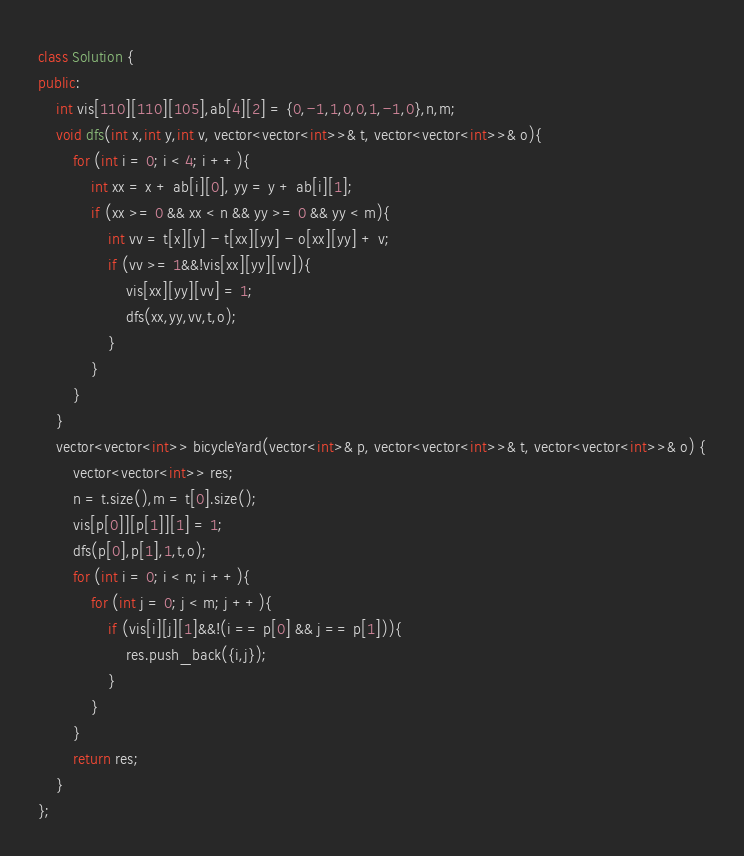Convert code to text. <code><loc_0><loc_0><loc_500><loc_500><_C++_>class Solution {
public:
    int vis[110][110][105],ab[4][2] = {0,-1,1,0,0,1,-1,0},n,m;
    void dfs(int x,int y,int v, vector<vector<int>>& t, vector<vector<int>>& o){
        for (int i = 0; i < 4; i ++){
            int xx = x + ab[i][0], yy = y + ab[i][1];
            if (xx >= 0 && xx < n && yy >= 0 && yy < m){
                int vv = t[x][y] - t[xx][yy] - o[xx][yy] + v;
                if (vv >= 1&&!vis[xx][yy][vv]){
                    vis[xx][yy][vv] = 1;
                    dfs(xx,yy,vv,t,o);
                }
            }
        }
    }
    vector<vector<int>> bicycleYard(vector<int>& p, vector<vector<int>>& t, vector<vector<int>>& o) {
        vector<vector<int>> res;
        n = t.size(),m = t[0].size();
        vis[p[0]][p[1]][1] = 1;
        dfs(p[0],p[1],1,t,o);
        for (int i = 0; i < n; i ++){
            for (int j = 0; j < m; j ++){
                if (vis[i][j][1]&&!(i == p[0] && j == p[1])){
                    res.push_back({i,j});
                }
            }
        }
        return res;
    }
};</code> 